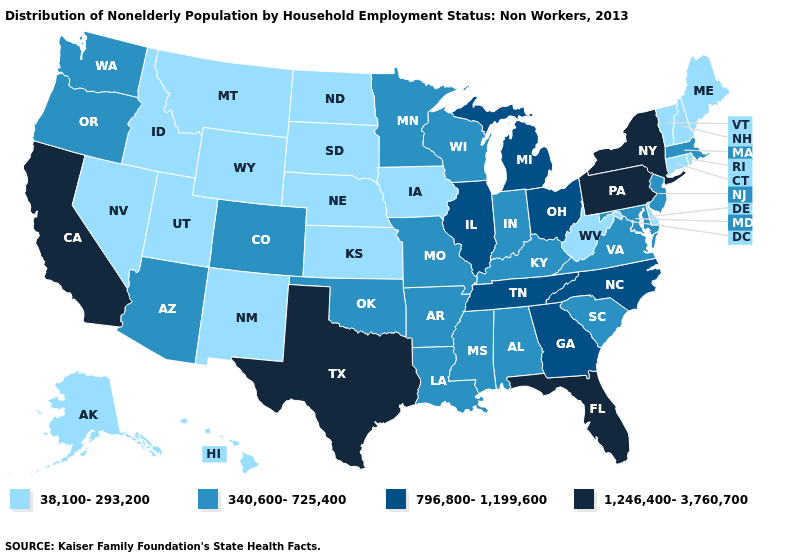Name the states that have a value in the range 1,246,400-3,760,700?
Quick response, please. California, Florida, New York, Pennsylvania, Texas. What is the value of Connecticut?
Answer briefly. 38,100-293,200. Name the states that have a value in the range 1,246,400-3,760,700?
Quick response, please. California, Florida, New York, Pennsylvania, Texas. Name the states that have a value in the range 1,246,400-3,760,700?
Answer briefly. California, Florida, New York, Pennsylvania, Texas. What is the value of Alabama?
Short answer required. 340,600-725,400. What is the lowest value in the USA?
Give a very brief answer. 38,100-293,200. Name the states that have a value in the range 1,246,400-3,760,700?
Answer briefly. California, Florida, New York, Pennsylvania, Texas. Name the states that have a value in the range 340,600-725,400?
Be succinct. Alabama, Arizona, Arkansas, Colorado, Indiana, Kentucky, Louisiana, Maryland, Massachusetts, Minnesota, Mississippi, Missouri, New Jersey, Oklahoma, Oregon, South Carolina, Virginia, Washington, Wisconsin. What is the value of Mississippi?
Write a very short answer. 340,600-725,400. What is the highest value in the Northeast ?
Give a very brief answer. 1,246,400-3,760,700. What is the value of Delaware?
Answer briefly. 38,100-293,200. Does the map have missing data?
Concise answer only. No. What is the value of California?
Write a very short answer. 1,246,400-3,760,700. Does the first symbol in the legend represent the smallest category?
Short answer required. Yes. 